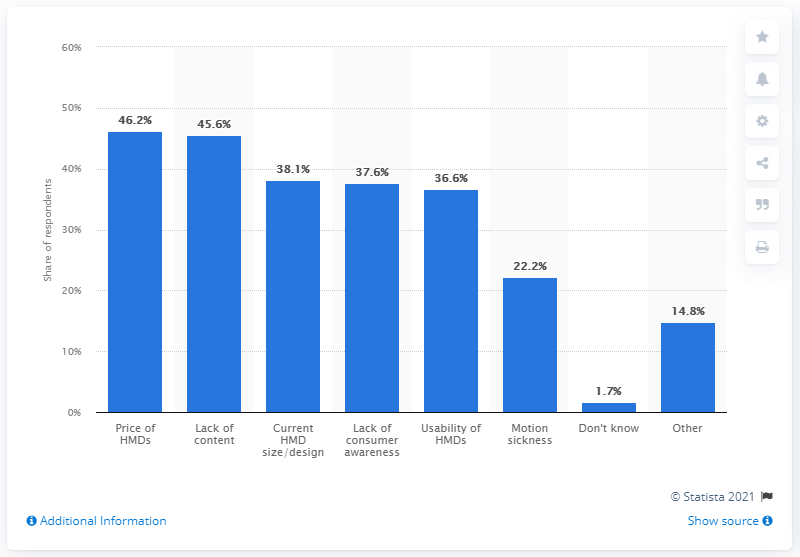Highlight a few significant elements in this photo. In a survey of extended reality (XR) professionals, 46.2% believed that the price of head-mounted displays (HMDs) was one of the main obstacles to the widespread adoption of XR technology. 